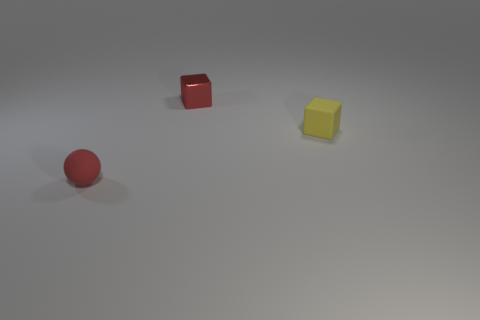What is the shape of the object that is made of the same material as the red ball?
Ensure brevity in your answer.  Cube. What number of tiny things are both to the left of the tiny rubber cube and behind the tiny red rubber object?
Offer a very short reply. 1. There is a rubber cube; are there any small red metallic objects on the right side of it?
Offer a terse response. No. There is a matte object that is to the left of the small rubber cube; does it have the same shape as the tiny object that is to the right of the small metal block?
Ensure brevity in your answer.  No. How many objects are either red shiny cubes or small objects that are to the left of the small red metal object?
Keep it short and to the point. 2. What number of other things are there of the same shape as the tiny shiny thing?
Give a very brief answer. 1. Is the thing that is on the right side of the metal block made of the same material as the tiny red cube?
Provide a short and direct response. No. How many objects are objects or small red shiny blocks?
Offer a very short reply. 3. The other yellow object that is the same shape as the metallic object is what size?
Offer a terse response. Small. The yellow matte thing is what size?
Provide a short and direct response. Small. 